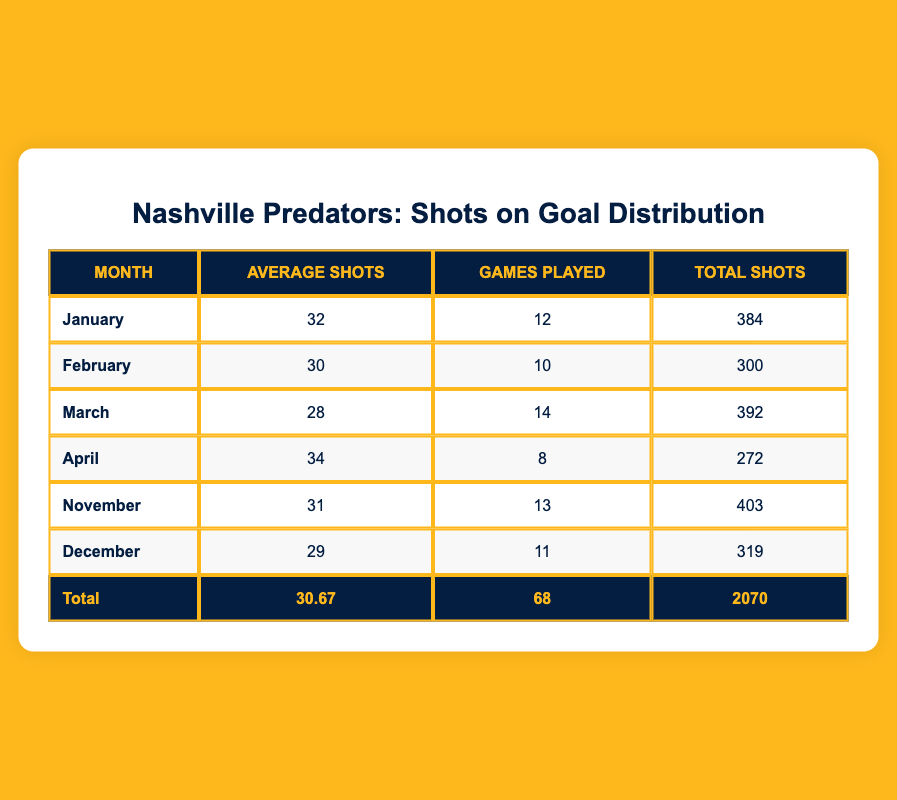What is the average number of shots on goal per month? To find the average number of shots on goal per month, we can divide the total shots by the number of months. The total shots for the months listed is 2070, and there are 6 months: 2070 / 6 = 345. Therefore, the average is approximately 345 shots per month.
Answer: 345 In which month did the Predators achieve the highest average shots on goal? Looking at the average shots column, January has the highest average with 32 shots. Therefore, January is the month with the highest average shots on goal.
Answer: January How many total shots did the team take in March? The total shots for March is specifically stated in the table as 392. Therefore, the answer is simply the value listed.
Answer: 392 Is it true that April had fewer total shots than December? For April, the total shots are 272, while for December, it is 319. Since 272 is less than 319, the statement is true that April had fewer total shots than December.
Answer: Yes What is the difference between the average shots in January and the average shots in April? From the data, the average shots in January is 32, and in April, it is 34. The difference is calculated as 34 - 32 = 2. Thus, the average shots in April exceed January's by 2 shots.
Answer: 2 Which month had the least number of games played? The month with the least number of games played listed is April, with only 8 games played. Hence, that is the answer.
Answer: April What is the total number of games played across all months? To find the total number of games played, we add all the games: 12 (January) + 10 (February) + 14 (March) + 8 (April) + 13 (November) + 11 (December) = 68. Hence, the total games played is 68.
Answer: 68 Did the team average more than 30 shots per game over the recorded months? The average shots overall was calculated as approximately 30.67 shots across all games, which exceeds 30, confirming the statement is true.
Answer: Yes How many more total shots did the team record in November than in February? For November, the total shots are 403, and for February, it is 300. The difference is calculated as 403 - 300 = 103. Thus, the team recorded 103 more total shots in November compared to February.
Answer: 103 